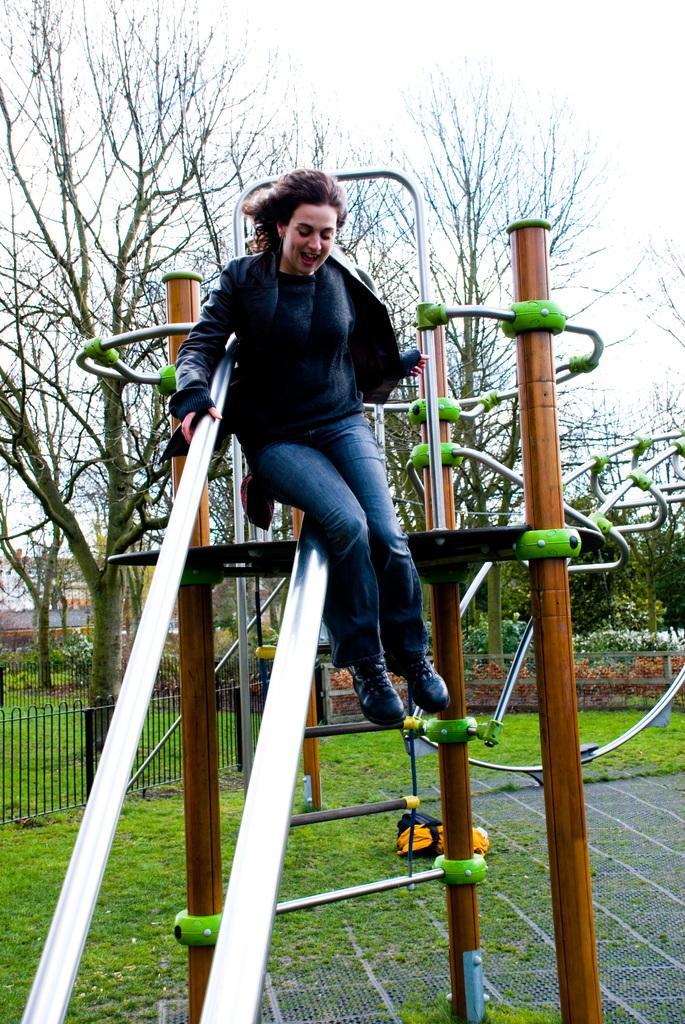Describe this image in one or two sentences. In this picture we can see a woman sitting on a steel object. There is some grass on the ground. We can see a few trees in the background. 